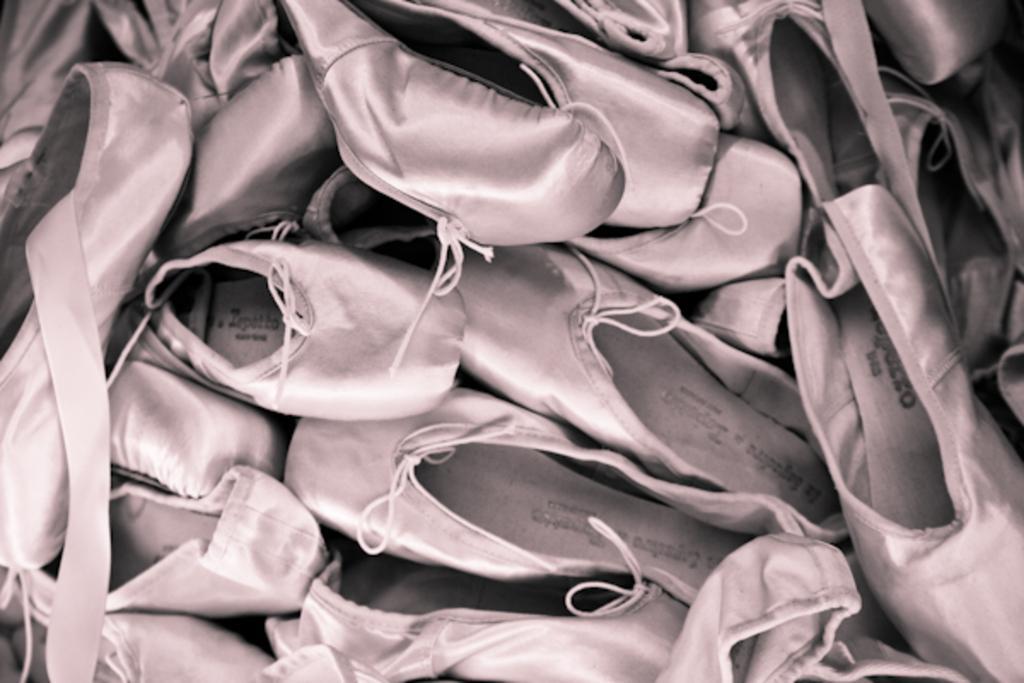Can you describe this image briefly? There are shoes in the image. 